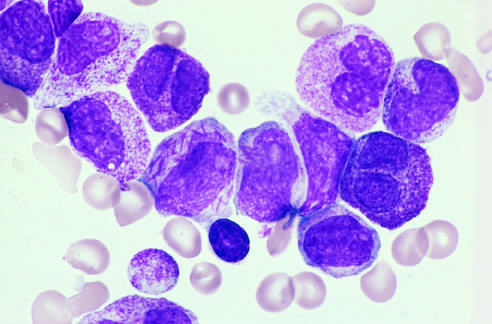what do other characteristic findings include?
Answer the question using a single word or phrase. A cell in the center of the field with multiple needlelike auer rods 